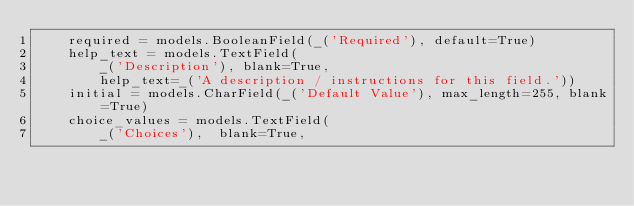Convert code to text. <code><loc_0><loc_0><loc_500><loc_500><_Python_>    required = models.BooleanField(_('Required'), default=True)
    help_text = models.TextField(
        _('Description'), blank=True,
        help_text=_('A description / instructions for this field.'))
    initial = models.CharField(_('Default Value'), max_length=255, blank=True)
    choice_values = models.TextField(
        _('Choices'),  blank=True,</code> 